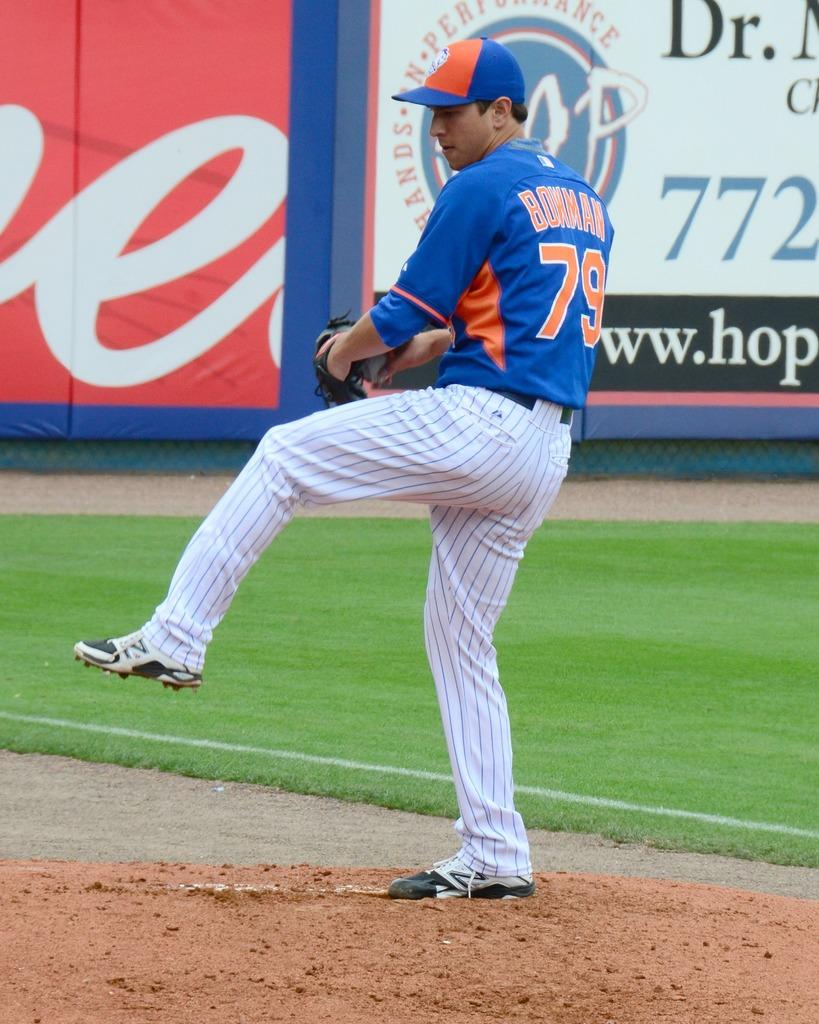Provide a one-sentence caption for the provided image. Player number 79 has one leg up as he prepares to throw the ball. 